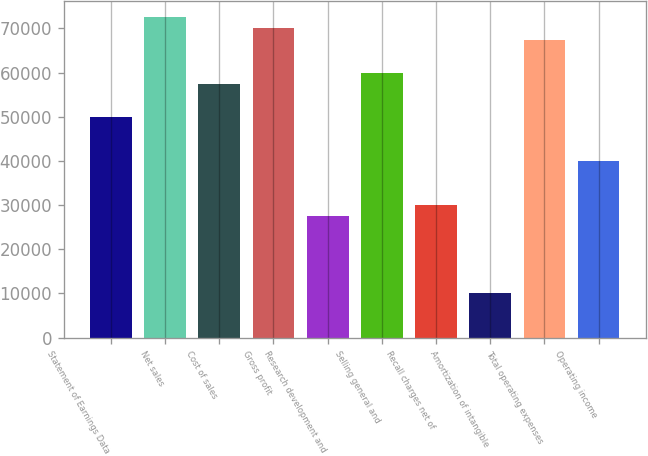Convert chart to OTSL. <chart><loc_0><loc_0><loc_500><loc_500><bar_chart><fcel>Statement of Earnings Data<fcel>Net sales<fcel>Cost of sales<fcel>Gross profit<fcel>Research development and<fcel>Selling general and<fcel>Recall charges net of<fcel>Amortization of intangible<fcel>Total operating expenses<fcel>Operating income<nl><fcel>49998.9<fcel>72497.9<fcel>57498.6<fcel>69998<fcel>27499.9<fcel>59998.5<fcel>29999.8<fcel>10000.7<fcel>67498.1<fcel>39999.3<nl></chart> 